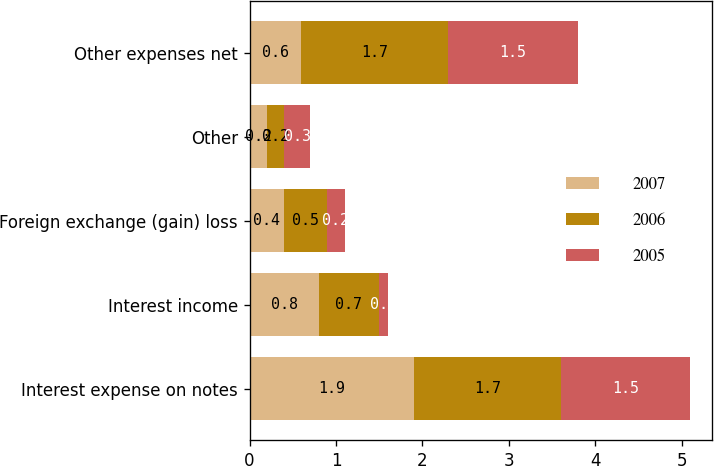Convert chart. <chart><loc_0><loc_0><loc_500><loc_500><stacked_bar_chart><ecel><fcel>Interest expense on notes<fcel>Interest income<fcel>Foreign exchange (gain) loss<fcel>Other<fcel>Other expenses net<nl><fcel>2007<fcel>1.9<fcel>0.8<fcel>0.4<fcel>0.2<fcel>0.6<nl><fcel>2006<fcel>1.7<fcel>0.7<fcel>0.5<fcel>0.2<fcel>1.7<nl><fcel>2005<fcel>1.5<fcel>0.1<fcel>0.2<fcel>0.3<fcel>1.5<nl></chart> 